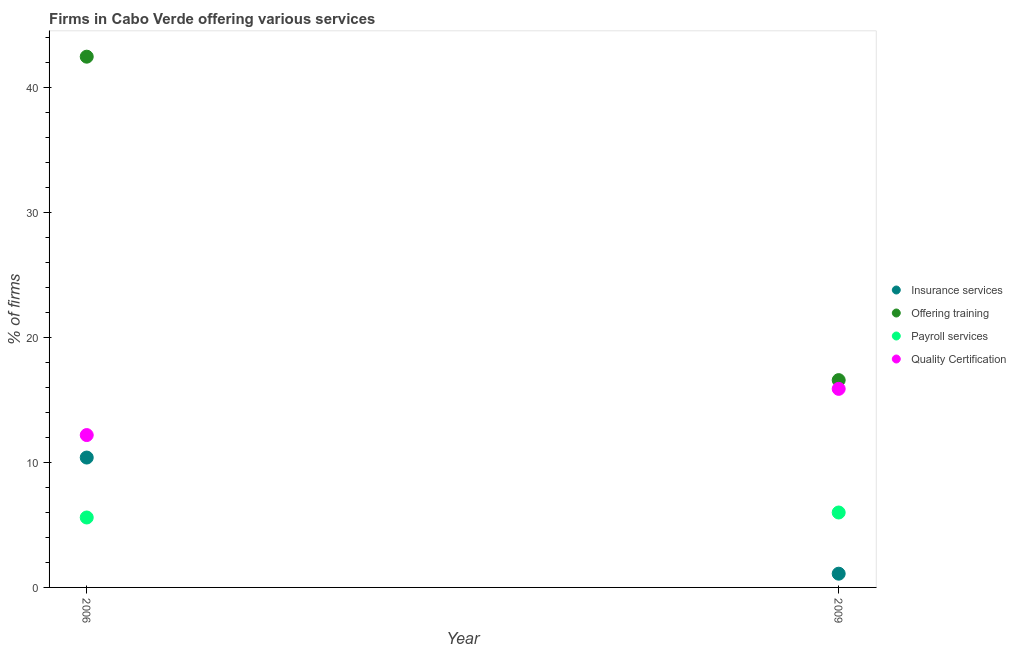Is the number of dotlines equal to the number of legend labels?
Ensure brevity in your answer.  Yes. Across all years, what is the maximum percentage of firms offering training?
Give a very brief answer. 42.5. Across all years, what is the minimum percentage of firms offering quality certification?
Your answer should be very brief. 12.2. In which year was the percentage of firms offering insurance services minimum?
Ensure brevity in your answer.  2009. What is the difference between the percentage of firms offering quality certification in 2006 and that in 2009?
Your answer should be compact. -3.7. What is the average percentage of firms offering training per year?
Offer a terse response. 29.55. In how many years, is the percentage of firms offering quality certification greater than 12 %?
Your answer should be very brief. 2. What is the ratio of the percentage of firms offering quality certification in 2006 to that in 2009?
Offer a terse response. 0.77. Is it the case that in every year, the sum of the percentage of firms offering insurance services and percentage of firms offering training is greater than the sum of percentage of firms offering payroll services and percentage of firms offering quality certification?
Ensure brevity in your answer.  No. Is it the case that in every year, the sum of the percentage of firms offering insurance services and percentage of firms offering training is greater than the percentage of firms offering payroll services?
Your answer should be very brief. Yes. Does the percentage of firms offering payroll services monotonically increase over the years?
Provide a short and direct response. Yes. Is the percentage of firms offering quality certification strictly greater than the percentage of firms offering training over the years?
Provide a succinct answer. No. How many dotlines are there?
Ensure brevity in your answer.  4. Does the graph contain any zero values?
Offer a terse response. No. How many legend labels are there?
Provide a succinct answer. 4. How are the legend labels stacked?
Offer a very short reply. Vertical. What is the title of the graph?
Your response must be concise. Firms in Cabo Verde offering various services . What is the label or title of the Y-axis?
Ensure brevity in your answer.  % of firms. What is the % of firms in Insurance services in 2006?
Your response must be concise. 10.4. What is the % of firms of Offering training in 2006?
Ensure brevity in your answer.  42.5. What is the % of firms in Quality Certification in 2006?
Provide a succinct answer. 12.2. What is the % of firms in Offering training in 2009?
Provide a short and direct response. 16.6. What is the % of firms in Payroll services in 2009?
Offer a terse response. 6. What is the % of firms of Quality Certification in 2009?
Your answer should be very brief. 15.9. Across all years, what is the maximum % of firms in Offering training?
Keep it short and to the point. 42.5. Across all years, what is the maximum % of firms of Payroll services?
Give a very brief answer. 6. Across all years, what is the minimum % of firms in Offering training?
Your answer should be very brief. 16.6. Across all years, what is the minimum % of firms in Payroll services?
Your answer should be compact. 5.6. Across all years, what is the minimum % of firms of Quality Certification?
Keep it short and to the point. 12.2. What is the total % of firms in Insurance services in the graph?
Provide a succinct answer. 11.5. What is the total % of firms in Offering training in the graph?
Your answer should be very brief. 59.1. What is the total % of firms of Payroll services in the graph?
Your answer should be compact. 11.6. What is the total % of firms of Quality Certification in the graph?
Provide a short and direct response. 28.1. What is the difference between the % of firms of Insurance services in 2006 and that in 2009?
Provide a short and direct response. 9.3. What is the difference between the % of firms of Offering training in 2006 and that in 2009?
Your answer should be compact. 25.9. What is the difference between the % of firms of Payroll services in 2006 and that in 2009?
Your answer should be very brief. -0.4. What is the difference between the % of firms in Insurance services in 2006 and the % of firms in Offering training in 2009?
Your answer should be very brief. -6.2. What is the difference between the % of firms of Insurance services in 2006 and the % of firms of Payroll services in 2009?
Provide a succinct answer. 4.4. What is the difference between the % of firms of Offering training in 2006 and the % of firms of Payroll services in 2009?
Provide a succinct answer. 36.5. What is the difference between the % of firms in Offering training in 2006 and the % of firms in Quality Certification in 2009?
Your answer should be compact. 26.6. What is the average % of firms of Insurance services per year?
Offer a terse response. 5.75. What is the average % of firms in Offering training per year?
Your answer should be compact. 29.55. What is the average % of firms of Quality Certification per year?
Offer a terse response. 14.05. In the year 2006, what is the difference between the % of firms of Insurance services and % of firms of Offering training?
Give a very brief answer. -32.1. In the year 2006, what is the difference between the % of firms in Offering training and % of firms in Payroll services?
Offer a very short reply. 36.9. In the year 2006, what is the difference between the % of firms in Offering training and % of firms in Quality Certification?
Ensure brevity in your answer.  30.3. In the year 2006, what is the difference between the % of firms of Payroll services and % of firms of Quality Certification?
Give a very brief answer. -6.6. In the year 2009, what is the difference between the % of firms of Insurance services and % of firms of Offering training?
Ensure brevity in your answer.  -15.5. In the year 2009, what is the difference between the % of firms in Insurance services and % of firms in Payroll services?
Your answer should be very brief. -4.9. In the year 2009, what is the difference between the % of firms of Insurance services and % of firms of Quality Certification?
Ensure brevity in your answer.  -14.8. In the year 2009, what is the difference between the % of firms in Offering training and % of firms in Payroll services?
Your response must be concise. 10.6. In the year 2009, what is the difference between the % of firms in Offering training and % of firms in Quality Certification?
Provide a succinct answer. 0.7. What is the ratio of the % of firms of Insurance services in 2006 to that in 2009?
Provide a short and direct response. 9.45. What is the ratio of the % of firms in Offering training in 2006 to that in 2009?
Provide a short and direct response. 2.56. What is the ratio of the % of firms of Quality Certification in 2006 to that in 2009?
Keep it short and to the point. 0.77. What is the difference between the highest and the second highest % of firms of Insurance services?
Provide a short and direct response. 9.3. What is the difference between the highest and the second highest % of firms in Offering training?
Offer a very short reply. 25.9. What is the difference between the highest and the lowest % of firms of Offering training?
Keep it short and to the point. 25.9. 